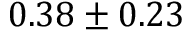<formula> <loc_0><loc_0><loc_500><loc_500>0 . 3 8 \pm 0 . 2 3</formula> 